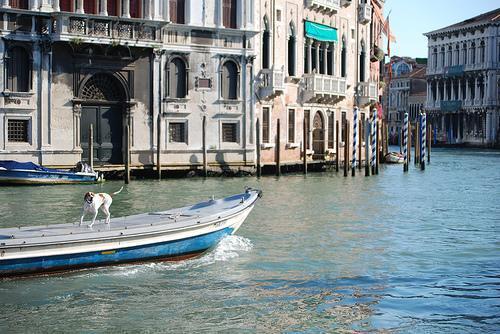How many dogs are there?
Give a very brief answer. 1. 